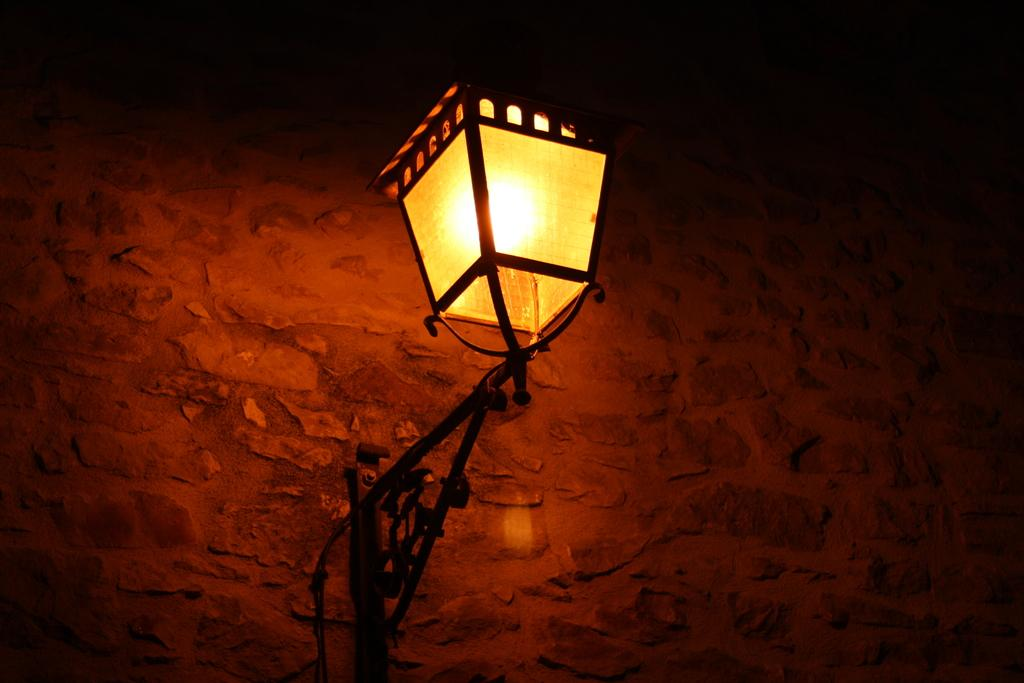What is located in the center of the image? There is a wall and a lamp in the center of the image. Can you describe the wall in the image? The wall is in the center of the image. What type of lighting fixture is present in the image? There is a lamp in the center of the image. What direction is the society moving in the image? There is no reference to a society or any movement in the image, so it's not possible to determine the direction of a society. 